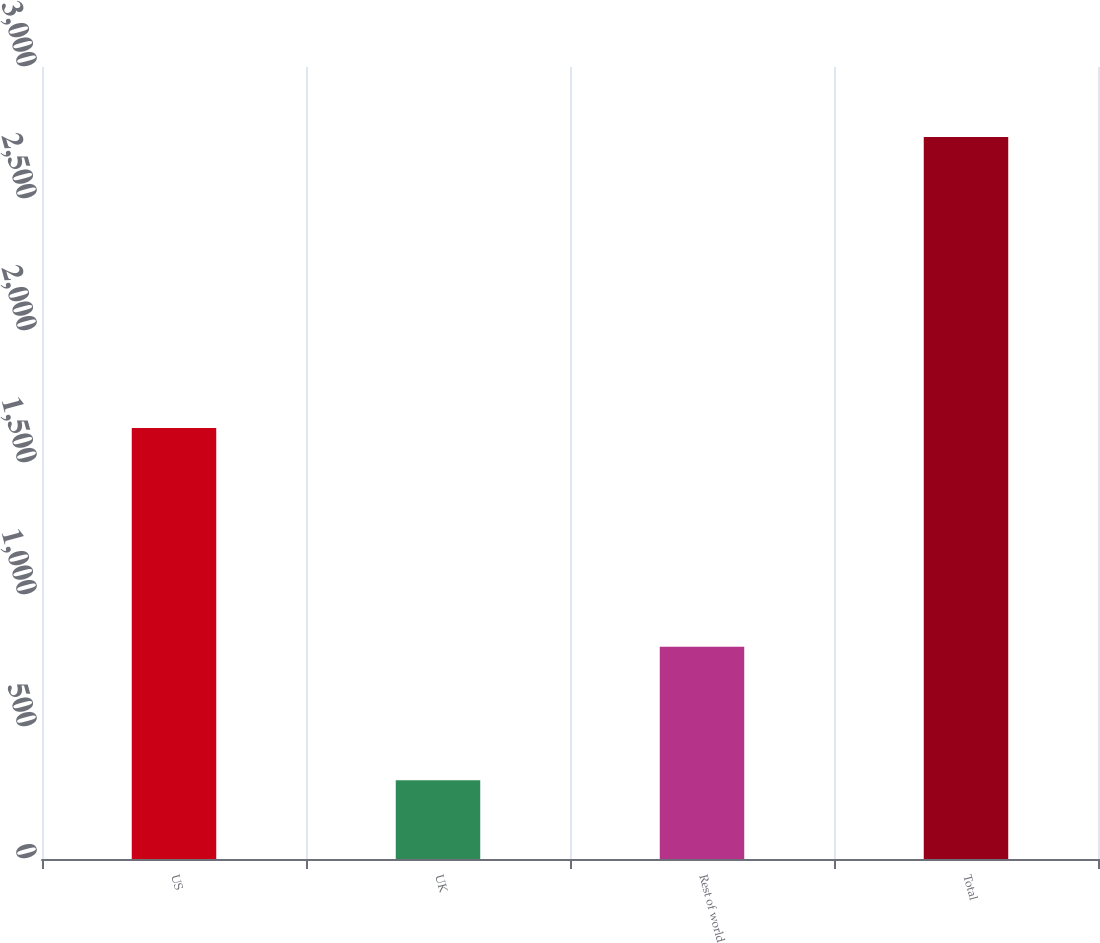Convert chart to OTSL. <chart><loc_0><loc_0><loc_500><loc_500><bar_chart><fcel>US<fcel>UK<fcel>Rest of world<fcel>Total<nl><fcel>1632.3<fcel>298.1<fcel>804.4<fcel>2734.8<nl></chart> 